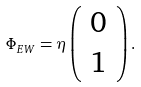Convert formula to latex. <formula><loc_0><loc_0><loc_500><loc_500>\Phi _ { E W } = \eta \left ( \begin{array} { c } 0 \\ 1 \end{array} \right ) .</formula> 